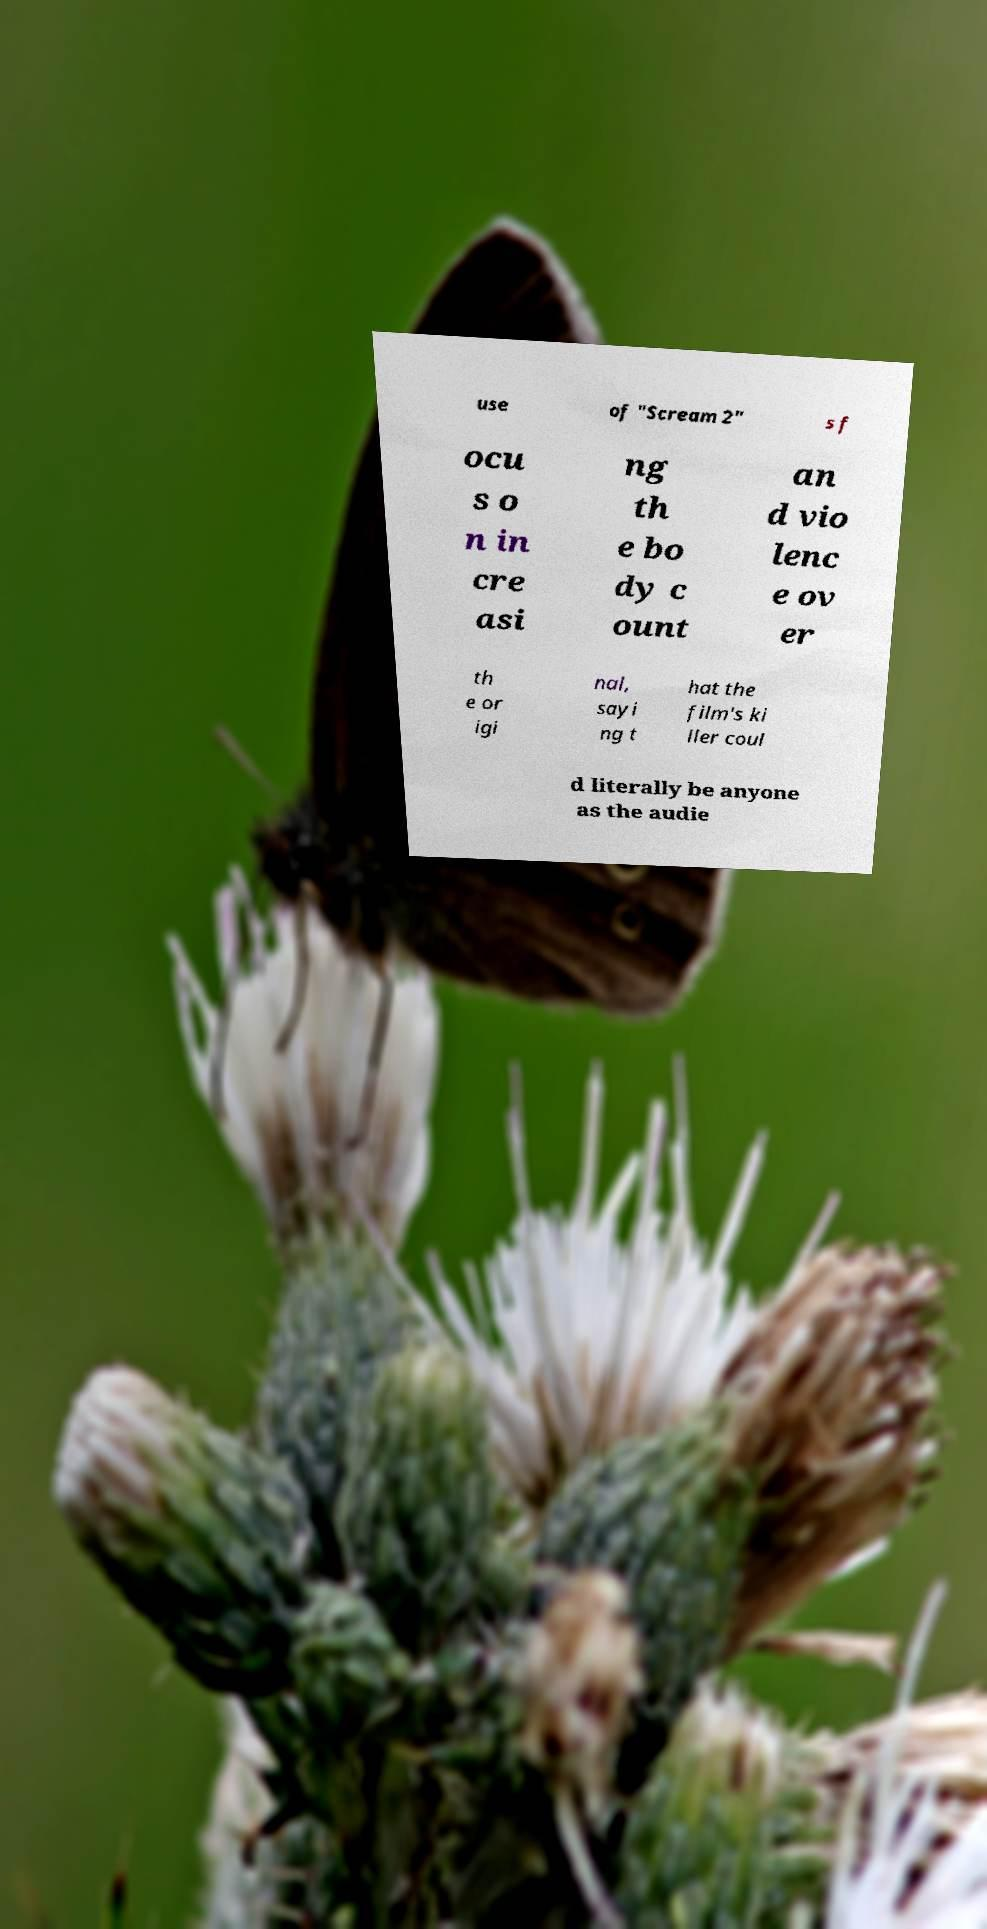Can you read and provide the text displayed in the image?This photo seems to have some interesting text. Can you extract and type it out for me? use of "Scream 2" s f ocu s o n in cre asi ng th e bo dy c ount an d vio lenc e ov er th e or igi nal, sayi ng t hat the film's ki ller coul d literally be anyone as the audie 